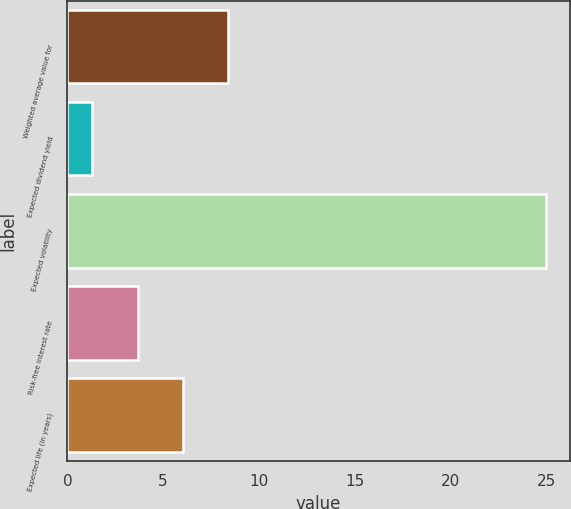<chart> <loc_0><loc_0><loc_500><loc_500><bar_chart><fcel>Weighted average value for<fcel>Expected dividend yield<fcel>Expected volatility<fcel>Risk-free interest rate<fcel>Expected life (in years)<nl><fcel>8.41<fcel>1.3<fcel>25<fcel>3.67<fcel>6.04<nl></chart> 